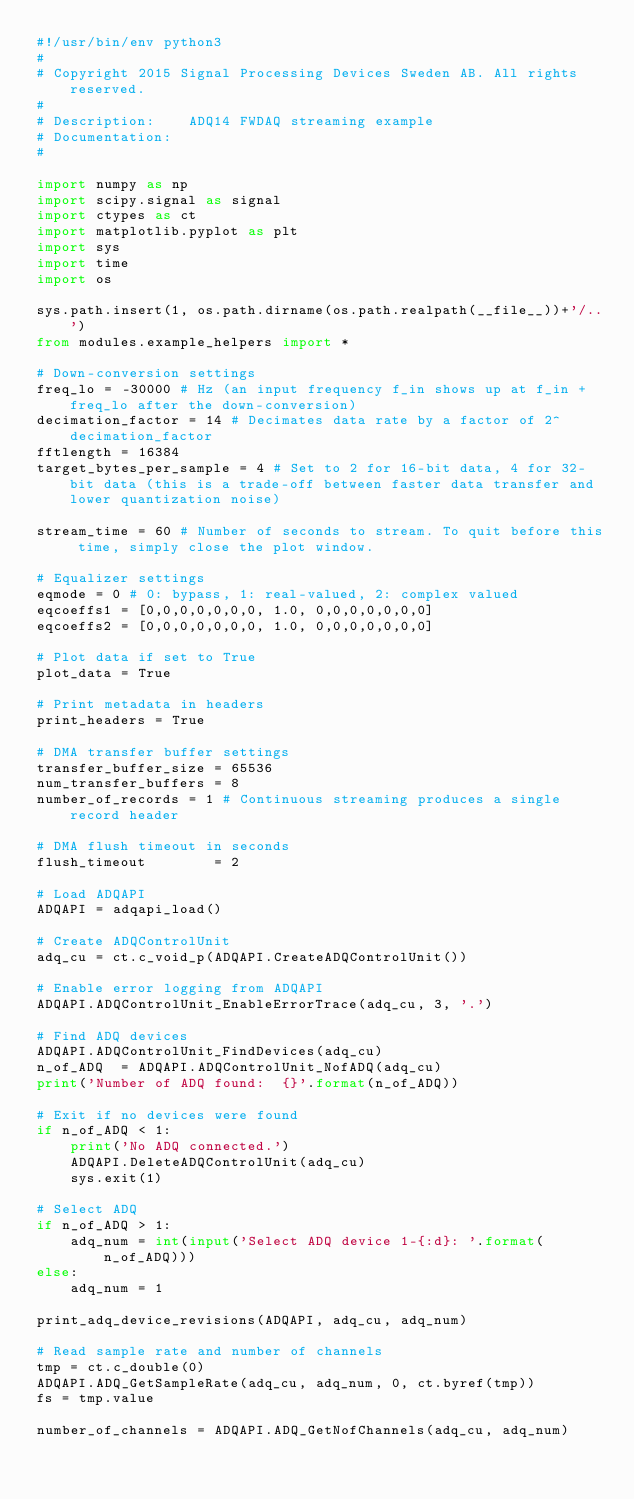Convert code to text. <code><loc_0><loc_0><loc_500><loc_500><_Python_>#!/usr/bin/env python3
#
# Copyright 2015 Signal Processing Devices Sweden AB. All rights reserved.
#
# Description:    ADQ14 FWDAQ streaming example
# Documentation:
#

import numpy as np
import scipy.signal as signal
import ctypes as ct
import matplotlib.pyplot as plt
import sys
import time
import os

sys.path.insert(1, os.path.dirname(os.path.realpath(__file__))+'/..')
from modules.example_helpers import *

# Down-conversion settings
freq_lo = -30000 # Hz (an input frequency f_in shows up at f_in + freq_lo after the down-conversion)
decimation_factor = 14 # Decimates data rate by a factor of 2^decimation_factor
fftlength = 16384
target_bytes_per_sample = 4 # Set to 2 for 16-bit data, 4 for 32-bit data (this is a trade-off between faster data transfer and lower quantization noise)

stream_time = 60 # Number of seconds to stream. To quit before this time, simply close the plot window.

# Equalizer settings
eqmode = 0 # 0: bypass, 1: real-valued, 2: complex valued
eqcoeffs1 = [0,0,0,0,0,0,0, 1.0, 0,0,0,0,0,0,0]
eqcoeffs2 = [0,0,0,0,0,0,0, 1.0, 0,0,0,0,0,0,0]

# Plot data if set to True
plot_data = True

# Print metadata in headers
print_headers = True

# DMA transfer buffer settings
transfer_buffer_size = 65536
num_transfer_buffers = 8
number_of_records = 1 # Continuous streaming produces a single record header

# DMA flush timeout in seconds
flush_timeout        = 2

# Load ADQAPI
ADQAPI = adqapi_load()

# Create ADQControlUnit
adq_cu = ct.c_void_p(ADQAPI.CreateADQControlUnit())

# Enable error logging from ADQAPI
ADQAPI.ADQControlUnit_EnableErrorTrace(adq_cu, 3, '.')

# Find ADQ devices
ADQAPI.ADQControlUnit_FindDevices(adq_cu)
n_of_ADQ  = ADQAPI.ADQControlUnit_NofADQ(adq_cu)
print('Number of ADQ found:  {}'.format(n_of_ADQ))

# Exit if no devices were found
if n_of_ADQ < 1:
    print('No ADQ connected.')
    ADQAPI.DeleteADQControlUnit(adq_cu)
    sys.exit(1)

# Select ADQ
if n_of_ADQ > 1:
    adq_num = int(input('Select ADQ device 1-{:d}: '.format(n_of_ADQ)))
else:
    adq_num = 1

print_adq_device_revisions(ADQAPI, adq_cu, adq_num)

# Read sample rate and number of channels
tmp = ct.c_double(0)
ADQAPI.ADQ_GetSampleRate(adq_cu, adq_num, 0, ct.byref(tmp))
fs = tmp.value

number_of_channels = ADQAPI.ADQ_GetNofChannels(adq_cu, adq_num)</code> 